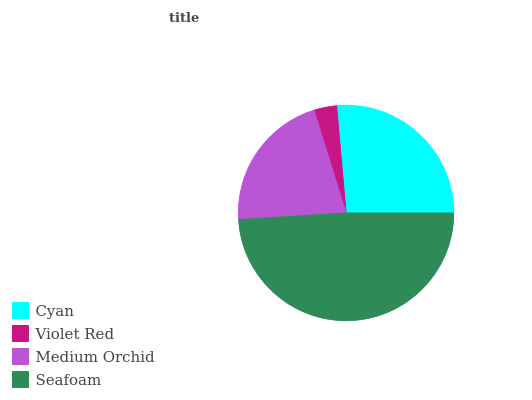Is Violet Red the minimum?
Answer yes or no. Yes. Is Seafoam the maximum?
Answer yes or no. Yes. Is Medium Orchid the minimum?
Answer yes or no. No. Is Medium Orchid the maximum?
Answer yes or no. No. Is Medium Orchid greater than Violet Red?
Answer yes or no. Yes. Is Violet Red less than Medium Orchid?
Answer yes or no. Yes. Is Violet Red greater than Medium Orchid?
Answer yes or no. No. Is Medium Orchid less than Violet Red?
Answer yes or no. No. Is Cyan the high median?
Answer yes or no. Yes. Is Medium Orchid the low median?
Answer yes or no. Yes. Is Seafoam the high median?
Answer yes or no. No. Is Cyan the low median?
Answer yes or no. No. 